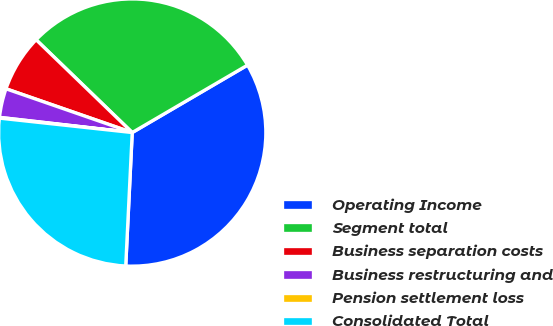Convert chart. <chart><loc_0><loc_0><loc_500><loc_500><pie_chart><fcel>Operating Income<fcel>Segment total<fcel>Business separation costs<fcel>Business restructuring and<fcel>Pension settlement loss<fcel>Consolidated Total<nl><fcel>34.2%<fcel>29.36%<fcel>6.91%<fcel>3.5%<fcel>0.09%<fcel>25.95%<nl></chart> 